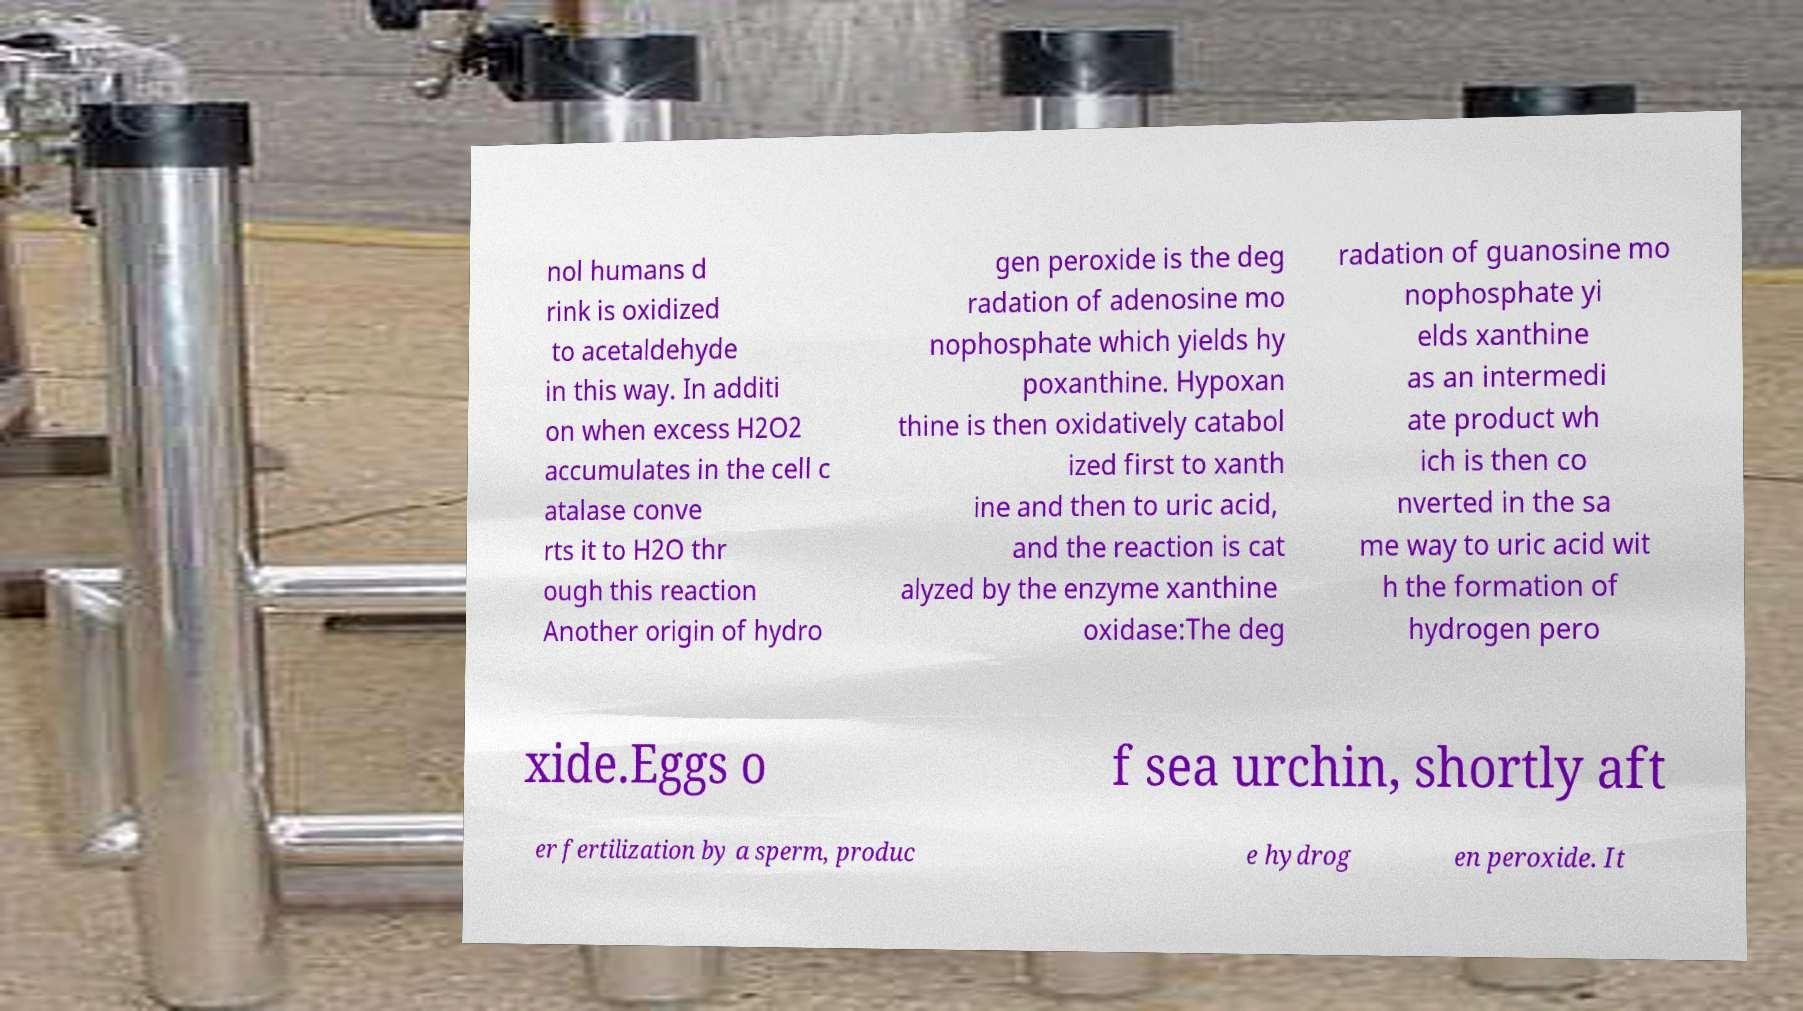Please identify and transcribe the text found in this image. nol humans d rink is oxidized to acetaldehyde in this way. In additi on when excess H2O2 accumulates in the cell c atalase conve rts it to H2O thr ough this reaction Another origin of hydro gen peroxide is the deg radation of adenosine mo nophosphate which yields hy poxanthine. Hypoxan thine is then oxidatively catabol ized first to xanth ine and then to uric acid, and the reaction is cat alyzed by the enzyme xanthine oxidase:The deg radation of guanosine mo nophosphate yi elds xanthine as an intermedi ate product wh ich is then co nverted in the sa me way to uric acid wit h the formation of hydrogen pero xide.Eggs o f sea urchin, shortly aft er fertilization by a sperm, produc e hydrog en peroxide. It 